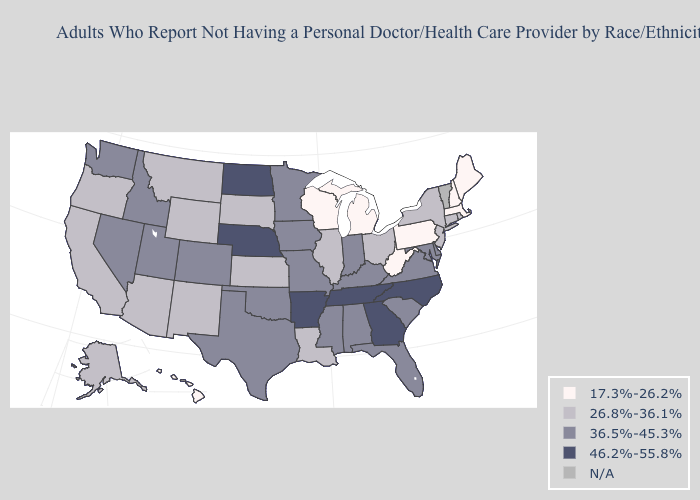Among the states that border Nebraska , does Colorado have the highest value?
Keep it brief. Yes. What is the lowest value in states that border Colorado?
Concise answer only. 26.8%-36.1%. Among the states that border California , does Oregon have the lowest value?
Short answer required. Yes. Among the states that border Kansas , does Oklahoma have the highest value?
Concise answer only. No. Which states hav the highest value in the MidWest?
Give a very brief answer. Nebraska, North Dakota. Name the states that have a value in the range 36.5%-45.3%?
Answer briefly. Alabama, Colorado, Delaware, Florida, Idaho, Indiana, Iowa, Kentucky, Maryland, Minnesota, Mississippi, Missouri, Nevada, Oklahoma, South Carolina, Texas, Utah, Virginia, Washington. What is the value of Vermont?
Be succinct. N/A. Does the first symbol in the legend represent the smallest category?
Give a very brief answer. Yes. What is the highest value in the West ?
Give a very brief answer. 36.5%-45.3%. What is the value of West Virginia?
Keep it brief. 17.3%-26.2%. What is the highest value in states that border Iowa?
Concise answer only. 46.2%-55.8%. Name the states that have a value in the range N/A?
Keep it brief. Vermont. 